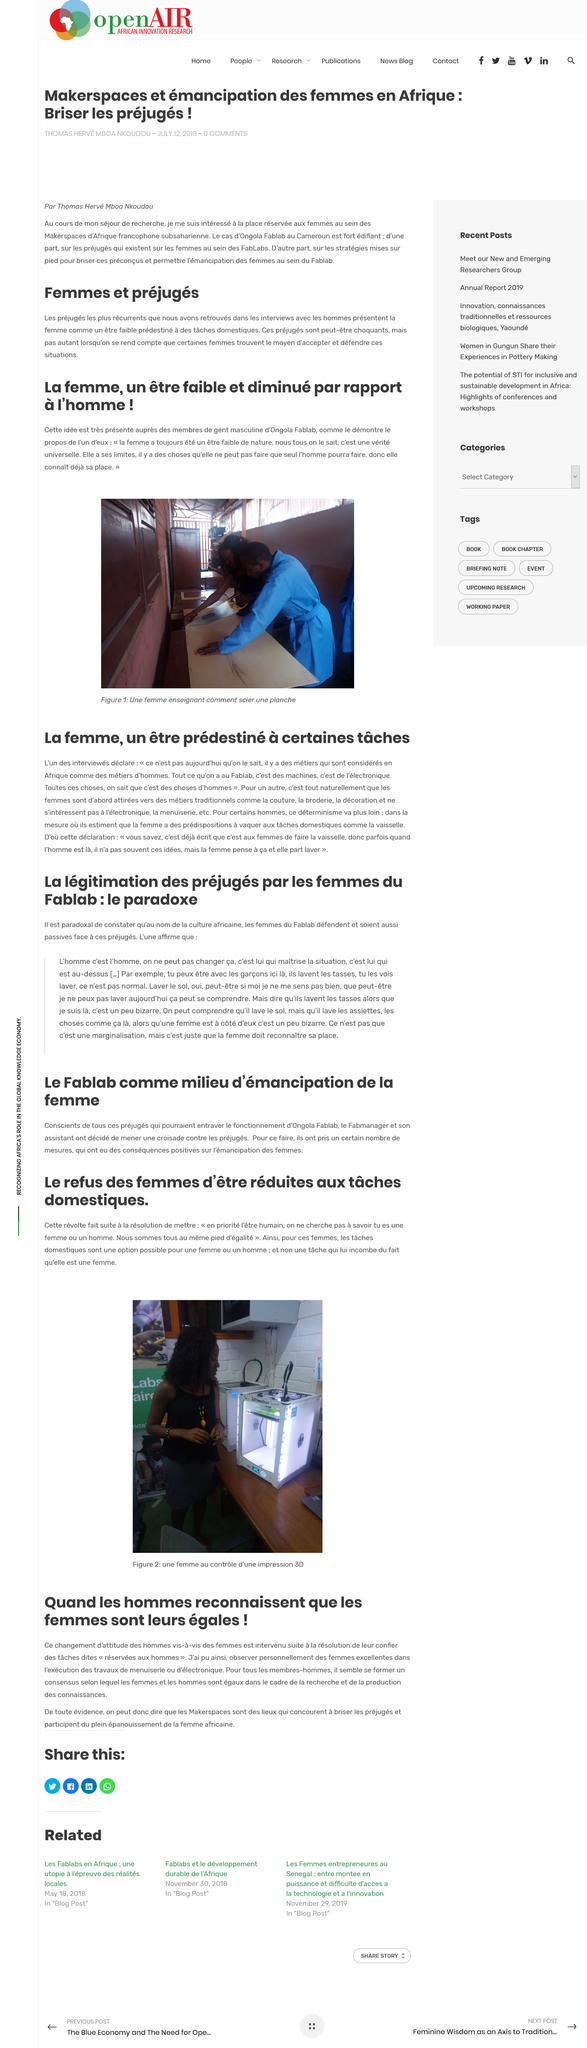Highlight a few significant elements in this photo. The image depicts two individuals examining a wooden plank, potentially evaluating its quality and construction as a bench. Women are attracted to careers in sewing, embroidery, and decoration. The things belonging to humans are those that are related to machines and electronics. According to the text, the woman is defined as an being predestined to certain tasks. Makerspaces are locations designed to break down stereotypes and promote the full development of African women. These spaces aim to provide opportunities for women to explore and develop their skills in various fields, challenging societal preconceptions and promoting gender equality. 